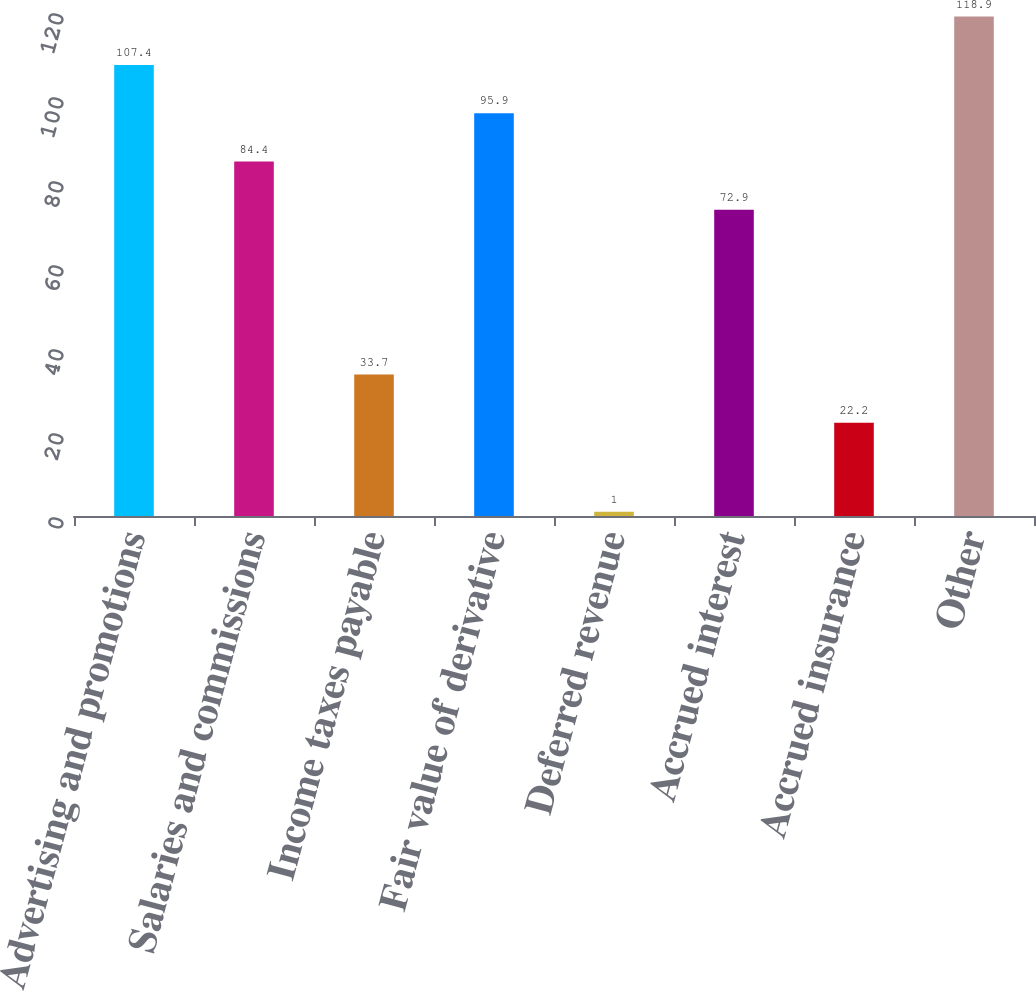Convert chart to OTSL. <chart><loc_0><loc_0><loc_500><loc_500><bar_chart><fcel>Advertising and promotions<fcel>Salaries and commissions<fcel>Income taxes payable<fcel>Fair value of derivative<fcel>Deferred revenue<fcel>Accrued interest<fcel>Accrued insurance<fcel>Other<nl><fcel>107.4<fcel>84.4<fcel>33.7<fcel>95.9<fcel>1<fcel>72.9<fcel>22.2<fcel>118.9<nl></chart> 